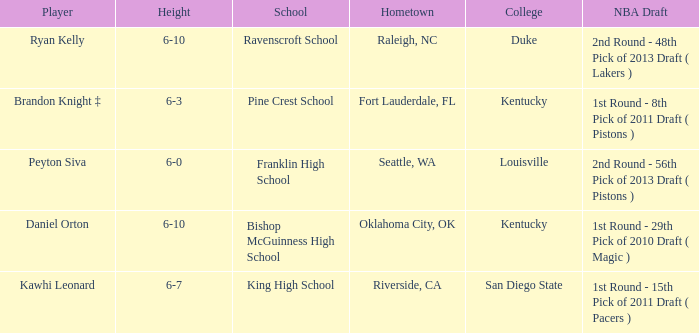Which height is associated with Franklin High School? 6-0. 